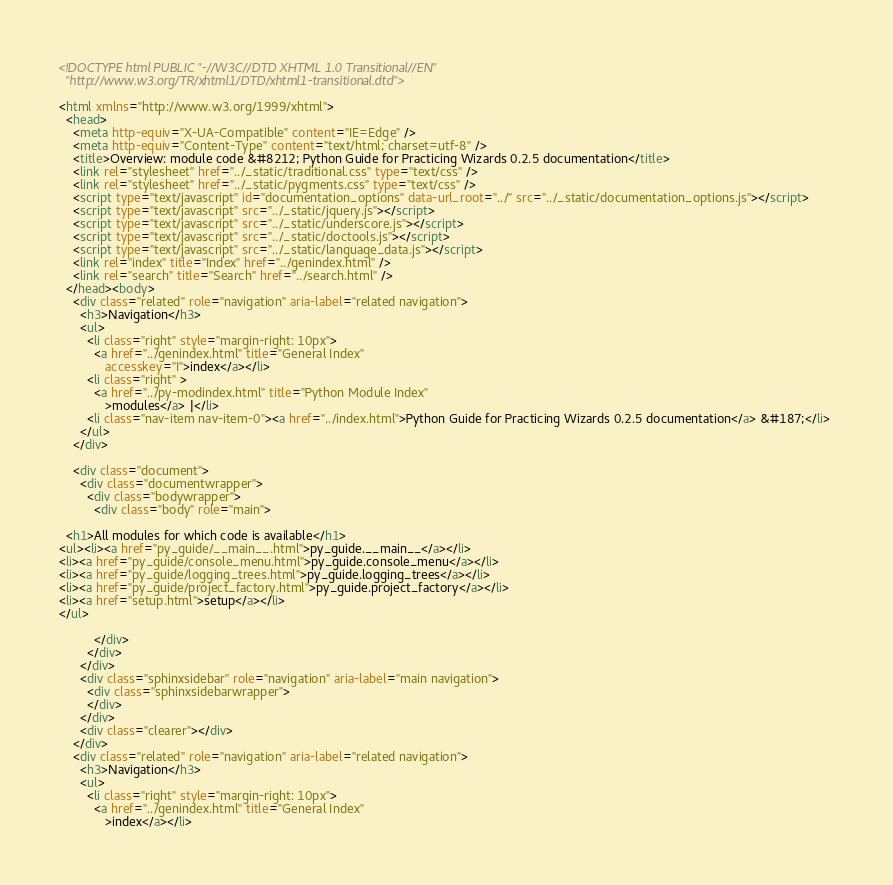<code> <loc_0><loc_0><loc_500><loc_500><_HTML_>
<!DOCTYPE html PUBLIC "-//W3C//DTD XHTML 1.0 Transitional//EN"
  "http://www.w3.org/TR/xhtml1/DTD/xhtml1-transitional.dtd">

<html xmlns="http://www.w3.org/1999/xhtml">
  <head>
    <meta http-equiv="X-UA-Compatible" content="IE=Edge" />
    <meta http-equiv="Content-Type" content="text/html; charset=utf-8" />
    <title>Overview: module code &#8212; Python Guide for Practicing Wizards 0.2.5 documentation</title>
    <link rel="stylesheet" href="../_static/traditional.css" type="text/css" />
    <link rel="stylesheet" href="../_static/pygments.css" type="text/css" />
    <script type="text/javascript" id="documentation_options" data-url_root="../" src="../_static/documentation_options.js"></script>
    <script type="text/javascript" src="../_static/jquery.js"></script>
    <script type="text/javascript" src="../_static/underscore.js"></script>
    <script type="text/javascript" src="../_static/doctools.js"></script>
    <script type="text/javascript" src="../_static/language_data.js"></script>
    <link rel="index" title="Index" href="../genindex.html" />
    <link rel="search" title="Search" href="../search.html" /> 
  </head><body>
    <div class="related" role="navigation" aria-label="related navigation">
      <h3>Navigation</h3>
      <ul>
        <li class="right" style="margin-right: 10px">
          <a href="../genindex.html" title="General Index"
             accesskey="I">index</a></li>
        <li class="right" >
          <a href="../py-modindex.html" title="Python Module Index"
             >modules</a> |</li>
        <li class="nav-item nav-item-0"><a href="../index.html">Python Guide for Practicing Wizards 0.2.5 documentation</a> &#187;</li> 
      </ul>
    </div>  

    <div class="document">
      <div class="documentwrapper">
        <div class="bodywrapper">
          <div class="body" role="main">
            
  <h1>All modules for which code is available</h1>
<ul><li><a href="py_guide/__main__.html">py_guide.__main__</a></li>
<li><a href="py_guide/console_menu.html">py_guide.console_menu</a></li>
<li><a href="py_guide/logging_trees.html">py_guide.logging_trees</a></li>
<li><a href="py_guide/project_factory.html">py_guide.project_factory</a></li>
<li><a href="setup.html">setup</a></li>
</ul>

          </div>
        </div>
      </div>
      <div class="sphinxsidebar" role="navigation" aria-label="main navigation">
        <div class="sphinxsidebarwrapper">
        </div>
      </div>
      <div class="clearer"></div>
    </div>
    <div class="related" role="navigation" aria-label="related navigation">
      <h3>Navigation</h3>
      <ul>
        <li class="right" style="margin-right: 10px">
          <a href="../genindex.html" title="General Index"
             >index</a></li></code> 